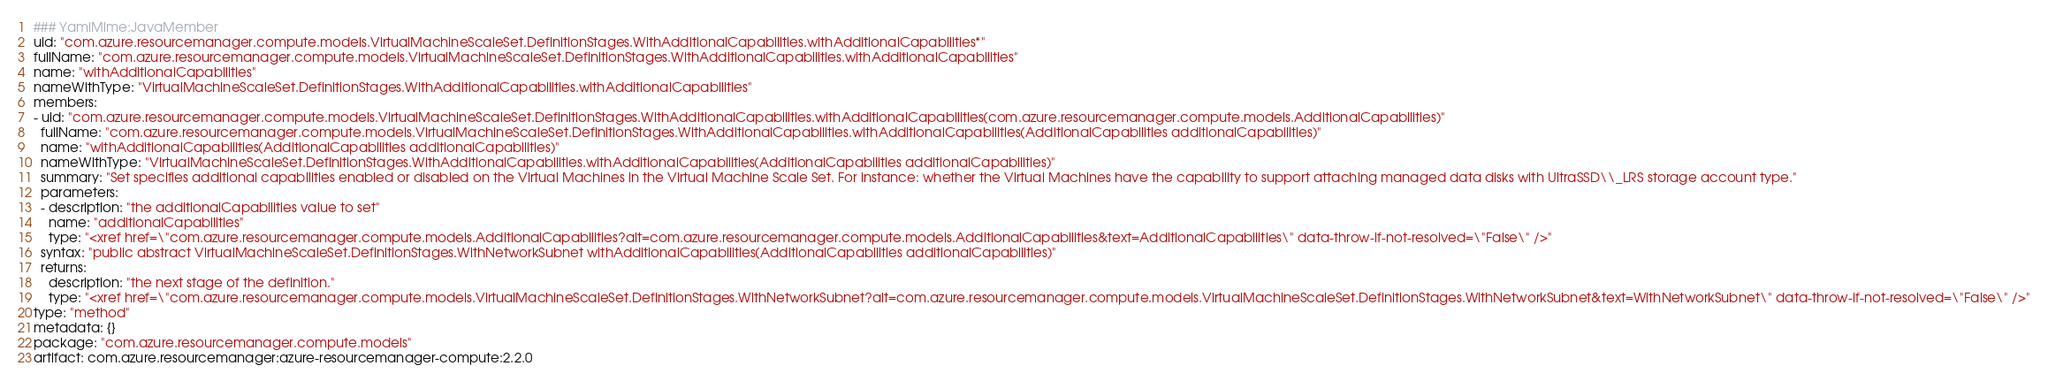<code> <loc_0><loc_0><loc_500><loc_500><_YAML_>### YamlMime:JavaMember
uid: "com.azure.resourcemanager.compute.models.VirtualMachineScaleSet.DefinitionStages.WithAdditionalCapabilities.withAdditionalCapabilities*"
fullName: "com.azure.resourcemanager.compute.models.VirtualMachineScaleSet.DefinitionStages.WithAdditionalCapabilities.withAdditionalCapabilities"
name: "withAdditionalCapabilities"
nameWithType: "VirtualMachineScaleSet.DefinitionStages.WithAdditionalCapabilities.withAdditionalCapabilities"
members:
- uid: "com.azure.resourcemanager.compute.models.VirtualMachineScaleSet.DefinitionStages.WithAdditionalCapabilities.withAdditionalCapabilities(com.azure.resourcemanager.compute.models.AdditionalCapabilities)"
  fullName: "com.azure.resourcemanager.compute.models.VirtualMachineScaleSet.DefinitionStages.WithAdditionalCapabilities.withAdditionalCapabilities(AdditionalCapabilities additionalCapabilities)"
  name: "withAdditionalCapabilities(AdditionalCapabilities additionalCapabilities)"
  nameWithType: "VirtualMachineScaleSet.DefinitionStages.WithAdditionalCapabilities.withAdditionalCapabilities(AdditionalCapabilities additionalCapabilities)"
  summary: "Set specifies additional capabilities enabled or disabled on the Virtual Machines in the Virtual Machine Scale Set. For instance: whether the Virtual Machines have the capability to support attaching managed data disks with UltraSSD\\_LRS storage account type."
  parameters:
  - description: "the additionalCapabilities value to set"
    name: "additionalCapabilities"
    type: "<xref href=\"com.azure.resourcemanager.compute.models.AdditionalCapabilities?alt=com.azure.resourcemanager.compute.models.AdditionalCapabilities&text=AdditionalCapabilities\" data-throw-if-not-resolved=\"False\" />"
  syntax: "public abstract VirtualMachineScaleSet.DefinitionStages.WithNetworkSubnet withAdditionalCapabilities(AdditionalCapabilities additionalCapabilities)"
  returns:
    description: "the next stage of the definition."
    type: "<xref href=\"com.azure.resourcemanager.compute.models.VirtualMachineScaleSet.DefinitionStages.WithNetworkSubnet?alt=com.azure.resourcemanager.compute.models.VirtualMachineScaleSet.DefinitionStages.WithNetworkSubnet&text=WithNetworkSubnet\" data-throw-if-not-resolved=\"False\" />"
type: "method"
metadata: {}
package: "com.azure.resourcemanager.compute.models"
artifact: com.azure.resourcemanager:azure-resourcemanager-compute:2.2.0
</code> 